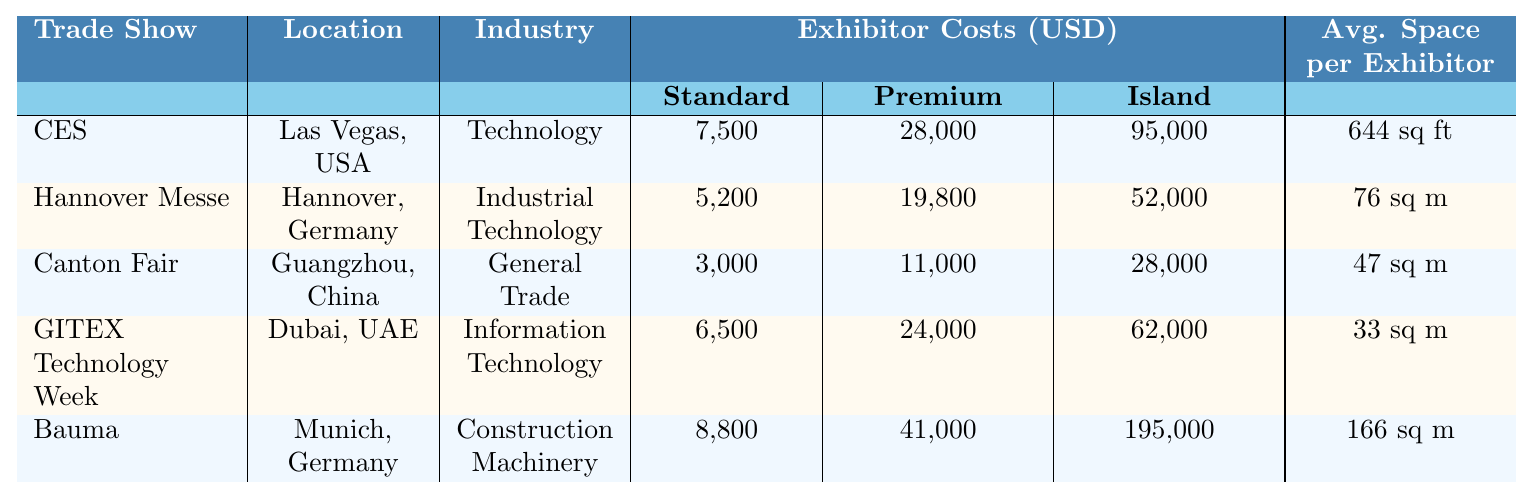What is the exhibitor cost for a standard booth at CES? The exhibitor cost for a standard booth at CES is listed under the "Exhibitor Costs" section of the table. It is clearly stated as 7,500 USD.
Answer: 7,500 USD What is the total exhibition area for Hannover Messe? The total exhibition area for Hannover Messe is given in the "Space Allocation" section of the table, which states it is 496,000 square meters.
Answer: 496,000 sq m True or False: The average space per exhibitor at GITEX Technology Week is larger than that at Bauma. The average space per exhibitor at GITEX Technology Week is 33 sq m, whereas at Bauma it is 166 sq m. Since 33 is less than 166, the answer is False.
Answer: False What is the difference in the cost of a premium booth between CES and GITEX Technology Week? The cost of a premium booth at CES is 28,000 USD, while at GITEX it is 24,000 USD. The difference is calculated as 28,000 - 24,000 = 4,000.
Answer: 4,000 USD Which trade show has the highest exhibitor cost for an island booth? Looking at the exhibitor cost for an island booth, CES has a cost of 95,000 USD, GITEX has 62,000 USD, Hannover Messe has 52,000 USD, Canton Fair has 28,000 USD, and Bauma has 195,000 USD. The maximum value is 195,000 USD for Bauma.
Answer: Bauma Calculate the average exhibitor cost for a standard booth across all shows. The standard booth costs are: CES (7,500), Hannover Messe (5,200), Canton Fair (3,000), GITEX (6,500), and Bauma (8,800). Adding these gives 30,000. Dividing by 5 (the number of shows), gives 30,000 / 5 = 6,000.
Answer: 6,000 USD Which industry has the largest total exhibition area? By comparing the total exhibition areas: CES (2,900,000 sq ft), Hannover Messe (496,000 sq m), Canton Fair (1,185,000 sq m), GITEX (150,000 sq m), and Bauma (614,000 sq m), we need to know that 2,900,000 sq ft converts to about 269,000 sq m. The largest area is from Canton Fair with 1,185,000 sq m.
Answer: Canton Fair What is the total number of exhibitors across all five trade shows? The number of exhibitors is: CES (4,500), Hannover Messe (6,500), Canton Fair (25,000), GITEX (4,500), and Bauma (3,700). Adding these gives 4,500 + 6,500 + 25,000 + 4,500 + 3,700 = 44,200.
Answer: 44,200 exhibitors What is the average space per exhibitor for CES in square meters? The average space per exhibitor for CES is given as 644 sq ft. Converting that to square meters (1 sq ft = 0.092903 sq m), we do the calculation: 644 * 0.092903 ≈ 59.9 sq m.
Answer: ~59.9 sq m Which trade show has the lowest premium booth cost? The premium booth costs are as follows: CES (28,000), Hannover Messe (19,800), Canton Fair (11,000), GITEX (24,000), Bauma (41,000). Comparing these values, the lowest cost is 11,000 USD at Canton Fair.
Answer: Canton Fair 